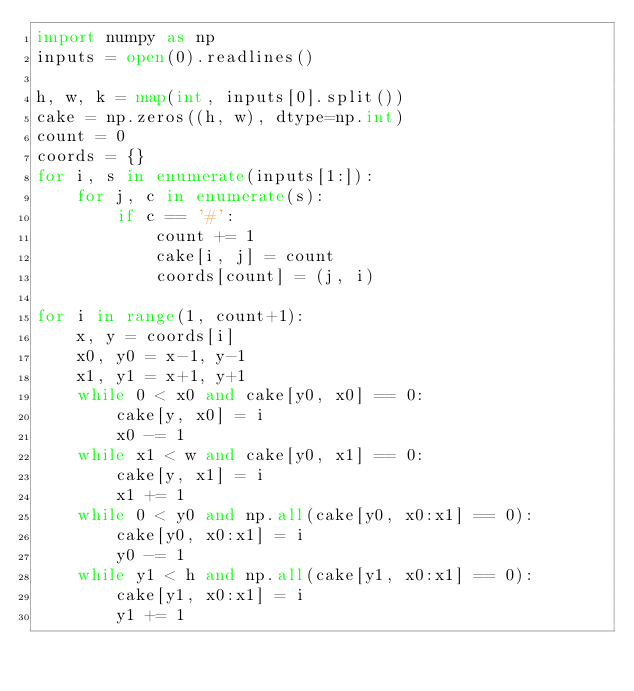<code> <loc_0><loc_0><loc_500><loc_500><_Python_>import numpy as np
inputs = open(0).readlines()

h, w, k = map(int, inputs[0].split())
cake = np.zeros((h, w), dtype=np.int)
count = 0
coords = {}
for i, s in enumerate(inputs[1:]):
    for j, c in enumerate(s):
        if c == '#':
            count += 1
            cake[i, j] = count
            coords[count] = (j, i)

for i in range(1, count+1):
    x, y = coords[i]
    x0, y0 = x-1, y-1
    x1, y1 = x+1, y+1
    while 0 < x0 and cake[y0, x0] == 0:
        cake[y, x0] = i
        x0 -= 1
    while x1 < w and cake[y0, x1] == 0:
        cake[y, x1] = i
        x1 += 1
    while 0 < y0 and np.all(cake[y0, x0:x1] == 0):
        cake[y0, x0:x1] = i
        y0 -= 1
    while y1 < h and np.all(cake[y1, x0:x1] == 0):
        cake[y1, x0:x1] = i
        y1 += 1</code> 